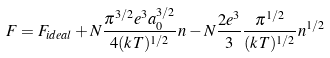<formula> <loc_0><loc_0><loc_500><loc_500>F = F _ { i d e a l } + N \frac { \pi ^ { 3 / 2 } e ^ { 3 } a _ { 0 } ^ { 3 / 2 } } { 4 ( k T ) ^ { 1 / 2 } } n - N \frac { 2 e ^ { 3 } } { 3 } \frac { \pi ^ { 1 / 2 } } { ( k T ) ^ { 1 / 2 } } n ^ { 1 / 2 }</formula> 